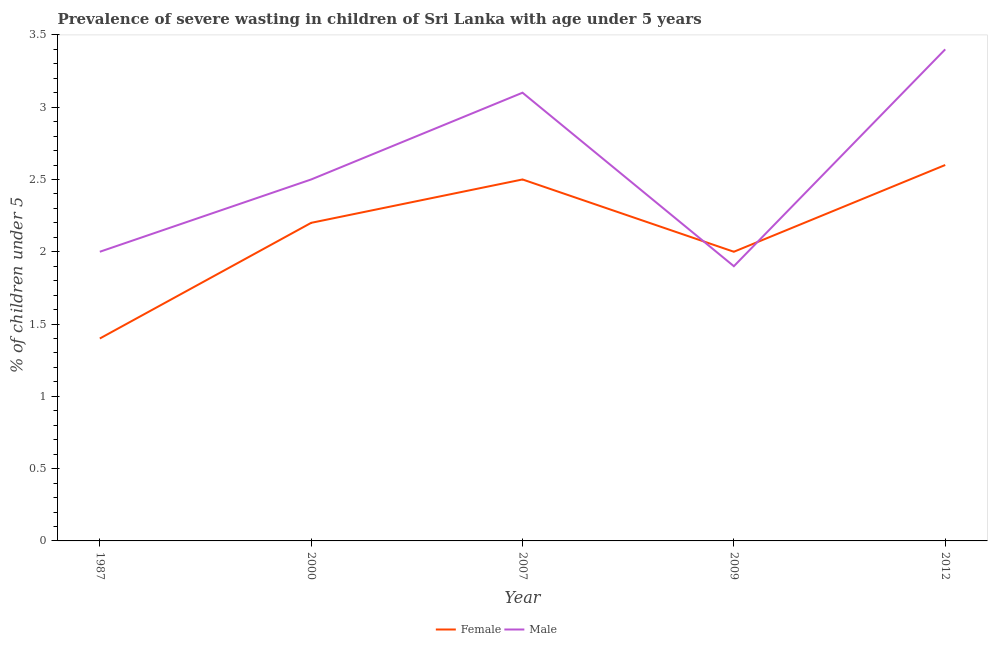Is the number of lines equal to the number of legend labels?
Provide a succinct answer. Yes. What is the percentage of undernourished male children in 2007?
Offer a terse response. 3.1. Across all years, what is the maximum percentage of undernourished male children?
Provide a short and direct response. 3.4. Across all years, what is the minimum percentage of undernourished female children?
Your response must be concise. 1.4. In which year was the percentage of undernourished female children minimum?
Ensure brevity in your answer.  1987. What is the total percentage of undernourished male children in the graph?
Make the answer very short. 12.9. What is the difference between the percentage of undernourished female children in 1987 and that in 2000?
Provide a succinct answer. -0.8. What is the difference between the percentage of undernourished female children in 2012 and the percentage of undernourished male children in 2000?
Keep it short and to the point. 0.1. What is the average percentage of undernourished male children per year?
Give a very brief answer. 2.58. In the year 2009, what is the difference between the percentage of undernourished male children and percentage of undernourished female children?
Ensure brevity in your answer.  -0.1. What is the ratio of the percentage of undernourished female children in 2000 to that in 2007?
Ensure brevity in your answer.  0.88. Is the percentage of undernourished male children in 1987 less than that in 2012?
Offer a terse response. Yes. Is the difference between the percentage of undernourished male children in 2007 and 2009 greater than the difference between the percentage of undernourished female children in 2007 and 2009?
Your answer should be very brief. Yes. What is the difference between the highest and the second highest percentage of undernourished female children?
Offer a terse response. 0.1. What is the difference between the highest and the lowest percentage of undernourished female children?
Your answer should be very brief. 1.2. In how many years, is the percentage of undernourished female children greater than the average percentage of undernourished female children taken over all years?
Provide a succinct answer. 3. Is the percentage of undernourished female children strictly less than the percentage of undernourished male children over the years?
Ensure brevity in your answer.  No. How many lines are there?
Give a very brief answer. 2. How many years are there in the graph?
Provide a succinct answer. 5. Are the values on the major ticks of Y-axis written in scientific E-notation?
Offer a very short reply. No. Does the graph contain any zero values?
Make the answer very short. No. Does the graph contain grids?
Your response must be concise. No. How are the legend labels stacked?
Keep it short and to the point. Horizontal. What is the title of the graph?
Your answer should be compact. Prevalence of severe wasting in children of Sri Lanka with age under 5 years. What is the label or title of the X-axis?
Offer a very short reply. Year. What is the label or title of the Y-axis?
Ensure brevity in your answer.   % of children under 5. What is the  % of children under 5 in Female in 1987?
Keep it short and to the point. 1.4. What is the  % of children under 5 of Female in 2000?
Provide a short and direct response. 2.2. What is the  % of children under 5 in Female in 2007?
Provide a succinct answer. 2.5. What is the  % of children under 5 in Male in 2007?
Ensure brevity in your answer.  3.1. What is the  % of children under 5 of Male in 2009?
Give a very brief answer. 1.9. What is the  % of children under 5 of Female in 2012?
Provide a succinct answer. 2.6. What is the  % of children under 5 of Male in 2012?
Your answer should be very brief. 3.4. Across all years, what is the maximum  % of children under 5 of Female?
Offer a very short reply. 2.6. Across all years, what is the maximum  % of children under 5 of Male?
Provide a short and direct response. 3.4. Across all years, what is the minimum  % of children under 5 of Female?
Ensure brevity in your answer.  1.4. Across all years, what is the minimum  % of children under 5 of Male?
Provide a short and direct response. 1.9. What is the total  % of children under 5 in Female in the graph?
Your answer should be very brief. 10.7. What is the difference between the  % of children under 5 of Female in 1987 and that in 2000?
Keep it short and to the point. -0.8. What is the difference between the  % of children under 5 of Female in 1987 and that in 2007?
Your answer should be compact. -1.1. What is the difference between the  % of children under 5 in Male in 1987 and that in 2007?
Make the answer very short. -1.1. What is the difference between the  % of children under 5 in Male in 1987 and that in 2009?
Your answer should be compact. 0.1. What is the difference between the  % of children under 5 of Female in 1987 and that in 2012?
Offer a very short reply. -1.2. What is the difference between the  % of children under 5 of Female in 2000 and that in 2007?
Give a very brief answer. -0.3. What is the difference between the  % of children under 5 of Male in 2000 and that in 2007?
Make the answer very short. -0.6. What is the difference between the  % of children under 5 of Male in 2000 and that in 2012?
Provide a succinct answer. -0.9. What is the difference between the  % of children under 5 in Female in 2007 and that in 2009?
Keep it short and to the point. 0.5. What is the difference between the  % of children under 5 of Male in 2007 and that in 2009?
Provide a short and direct response. 1.2. What is the difference between the  % of children under 5 of Female in 2007 and that in 2012?
Keep it short and to the point. -0.1. What is the difference between the  % of children under 5 of Male in 2007 and that in 2012?
Provide a succinct answer. -0.3. What is the difference between the  % of children under 5 of Male in 2009 and that in 2012?
Make the answer very short. -1.5. What is the difference between the  % of children under 5 of Female in 1987 and the  % of children under 5 of Male in 2000?
Keep it short and to the point. -1.1. What is the difference between the  % of children under 5 of Female in 1987 and the  % of children under 5 of Male in 2012?
Keep it short and to the point. -2. What is the difference between the  % of children under 5 of Female in 2000 and the  % of children under 5 of Male in 2007?
Ensure brevity in your answer.  -0.9. What is the difference between the  % of children under 5 in Female in 2000 and the  % of children under 5 in Male in 2009?
Ensure brevity in your answer.  0.3. What is the difference between the  % of children under 5 of Female in 2000 and the  % of children under 5 of Male in 2012?
Your answer should be very brief. -1.2. What is the difference between the  % of children under 5 in Female in 2007 and the  % of children under 5 in Male in 2012?
Offer a terse response. -0.9. What is the average  % of children under 5 of Female per year?
Ensure brevity in your answer.  2.14. What is the average  % of children under 5 in Male per year?
Keep it short and to the point. 2.58. In the year 1987, what is the difference between the  % of children under 5 in Female and  % of children under 5 in Male?
Keep it short and to the point. -0.6. In the year 2007, what is the difference between the  % of children under 5 of Female and  % of children under 5 of Male?
Offer a terse response. -0.6. In the year 2012, what is the difference between the  % of children under 5 in Female and  % of children under 5 in Male?
Your answer should be compact. -0.8. What is the ratio of the  % of children under 5 of Female in 1987 to that in 2000?
Offer a terse response. 0.64. What is the ratio of the  % of children under 5 of Male in 1987 to that in 2000?
Your response must be concise. 0.8. What is the ratio of the  % of children under 5 of Female in 1987 to that in 2007?
Keep it short and to the point. 0.56. What is the ratio of the  % of children under 5 in Male in 1987 to that in 2007?
Your answer should be compact. 0.65. What is the ratio of the  % of children under 5 of Male in 1987 to that in 2009?
Ensure brevity in your answer.  1.05. What is the ratio of the  % of children under 5 in Female in 1987 to that in 2012?
Provide a succinct answer. 0.54. What is the ratio of the  % of children under 5 of Male in 1987 to that in 2012?
Your response must be concise. 0.59. What is the ratio of the  % of children under 5 in Male in 2000 to that in 2007?
Ensure brevity in your answer.  0.81. What is the ratio of the  % of children under 5 of Male in 2000 to that in 2009?
Your answer should be compact. 1.32. What is the ratio of the  % of children under 5 in Female in 2000 to that in 2012?
Offer a very short reply. 0.85. What is the ratio of the  % of children under 5 in Male in 2000 to that in 2012?
Ensure brevity in your answer.  0.74. What is the ratio of the  % of children under 5 in Male in 2007 to that in 2009?
Your response must be concise. 1.63. What is the ratio of the  % of children under 5 of Female in 2007 to that in 2012?
Provide a short and direct response. 0.96. What is the ratio of the  % of children under 5 in Male in 2007 to that in 2012?
Your answer should be very brief. 0.91. What is the ratio of the  % of children under 5 of Female in 2009 to that in 2012?
Provide a succinct answer. 0.77. What is the ratio of the  % of children under 5 in Male in 2009 to that in 2012?
Make the answer very short. 0.56. What is the difference between the highest and the second highest  % of children under 5 in Female?
Provide a succinct answer. 0.1. What is the difference between the highest and the lowest  % of children under 5 in Male?
Make the answer very short. 1.5. 